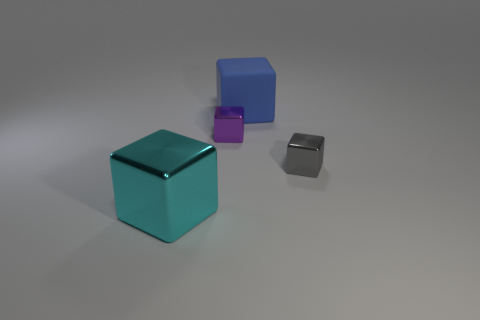Subtract 1 cubes. How many cubes are left? 3 Subtract all green blocks. Subtract all purple cylinders. How many blocks are left? 4 Add 2 brown metallic balls. How many objects exist? 6 Add 1 tiny purple metal blocks. How many tiny purple metal blocks exist? 2 Subtract 0 red blocks. How many objects are left? 4 Subtract all small metal blocks. Subtract all tiny blocks. How many objects are left? 0 Add 3 tiny gray blocks. How many tiny gray blocks are left? 4 